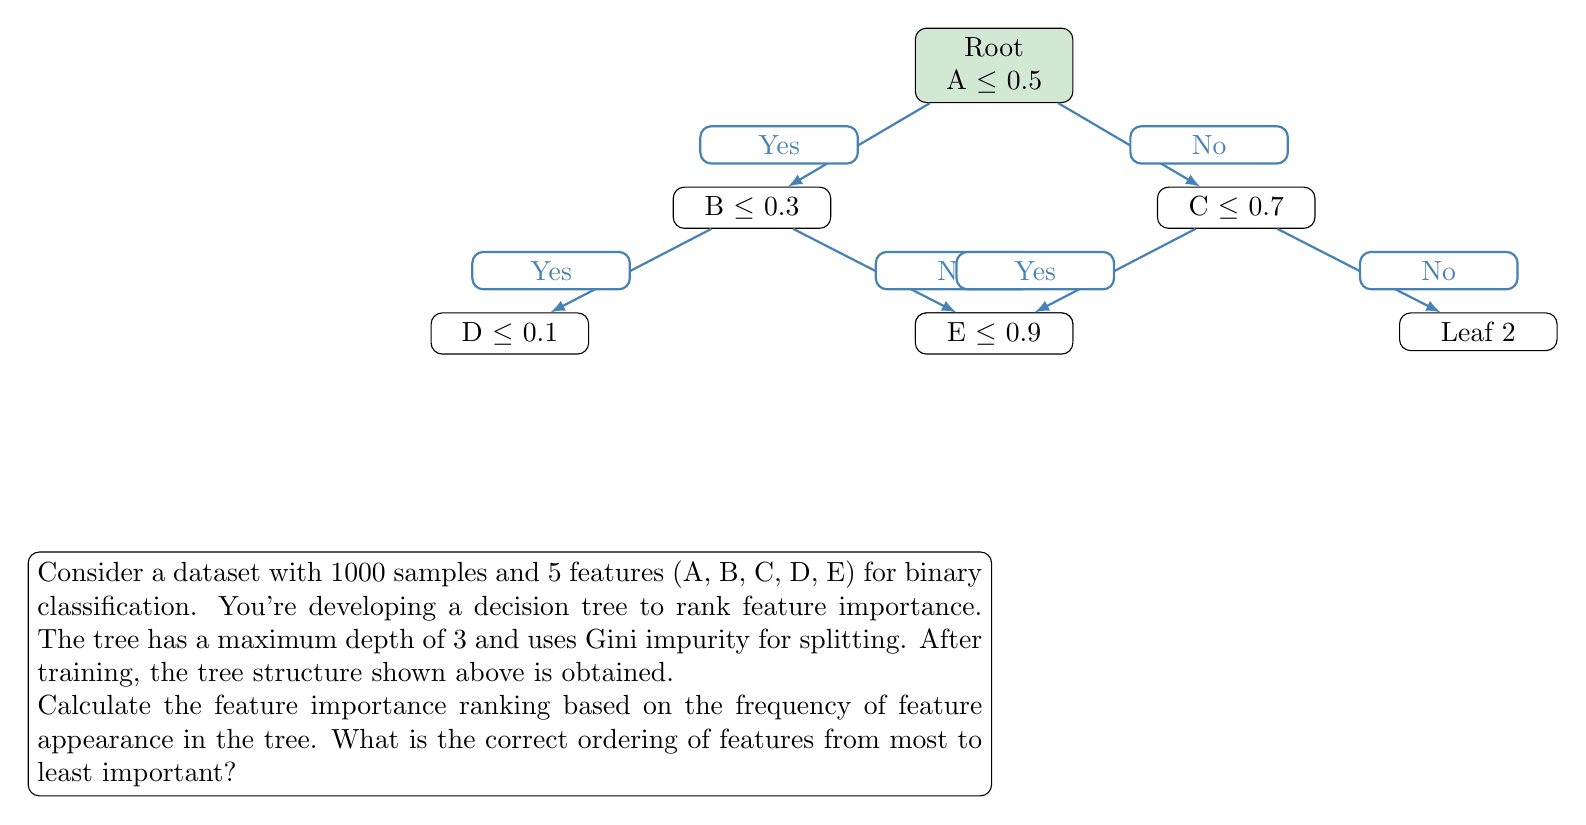Can you solve this math problem? To rank feature importance based on frequency of appearance in the decision tree, we need to count how many times each feature is used for splitting:

1. Count feature occurrences:
   - Feature A: 1 (root node)
   - Feature B: 1 (second level, left branch)
   - Feature C: 1 (second level, right branch)
   - Feature D: 1 (third level, leftmost branch)
   - Feature E: 1 (third level, second from right branch)

2. Analyze the tree structure:
   - The root node (Feature A) is the most important as it affects all samples.
   - Features B and C are at the second level, so they are equally important but less than A.
   - Features D and E are at the third level, so they are equally important but less than B and C.

3. Rank the features:
   - A is the most important (rank 1)
   - B and C are tied for second most important (rank 2)
   - D and E are tied for least important (rank 3)

4. Order the features from most to least important:
   A > (B = C) > (D = E)

Therefore, the correct ordering of features from most to least important is A, B, C, D, E, where B and C are interchangeable, and D and E are interchangeable.
Answer: A > (B = C) > (D = E) 